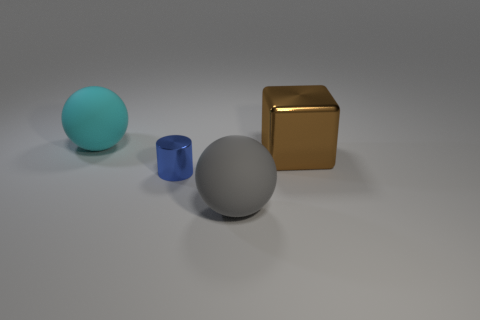There is a object that is both on the right side of the large cyan thing and behind the metal cylinder; what shape is it?
Your response must be concise. Cube. How big is the thing behind the brown metal thing?
Provide a succinct answer. Large. How many other blue things have the same shape as the small shiny object?
Ensure brevity in your answer.  0. How many objects are either big objects on the right side of the cylinder or matte spheres that are behind the large brown object?
Ensure brevity in your answer.  3. What number of purple objects are large blocks or cylinders?
Your response must be concise. 0. What is the thing that is both right of the blue shiny cylinder and in front of the brown object made of?
Provide a short and direct response. Rubber. Does the blue cylinder have the same material as the big gray object?
Provide a succinct answer. No. What number of cyan things are the same size as the gray sphere?
Ensure brevity in your answer.  1. Are there the same number of brown objects behind the large cyan sphere and big objects?
Ensure brevity in your answer.  No. What number of large spheres are both behind the tiny metallic cylinder and right of the cyan ball?
Provide a succinct answer. 0. 